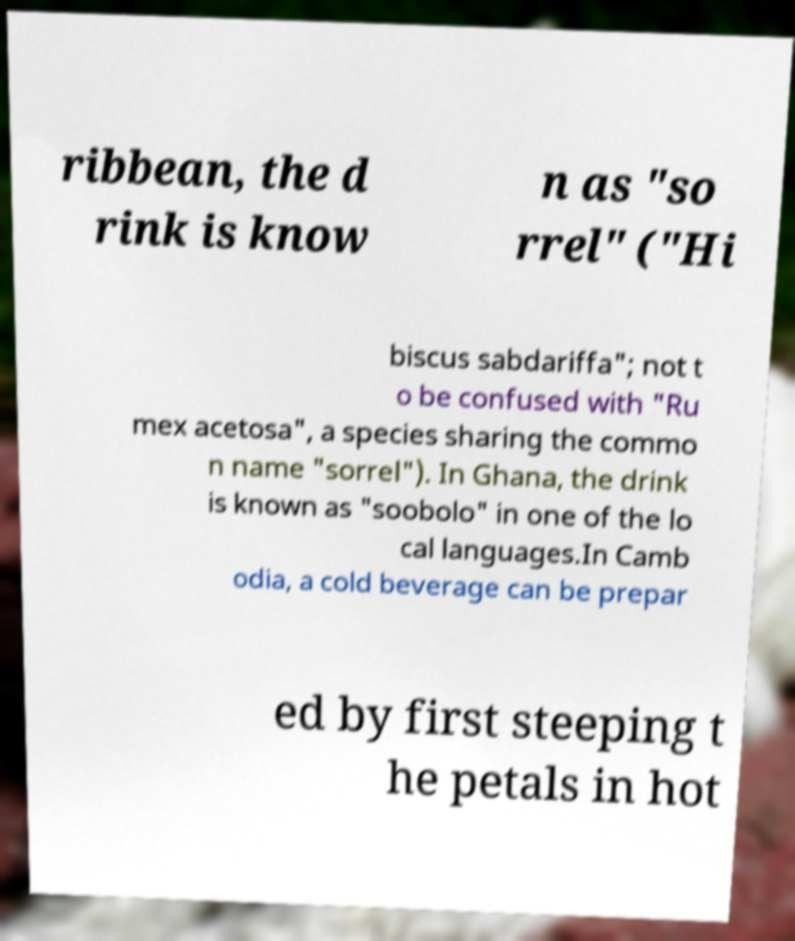I need the written content from this picture converted into text. Can you do that? ribbean, the d rink is know n as "so rrel" ("Hi biscus sabdariffa"; not t o be confused with "Ru mex acetosa", a species sharing the commo n name "sorrel"). In Ghana, the drink is known as "soobolo" in one of the lo cal languages.In Camb odia, a cold beverage can be prepar ed by first steeping t he petals in hot 